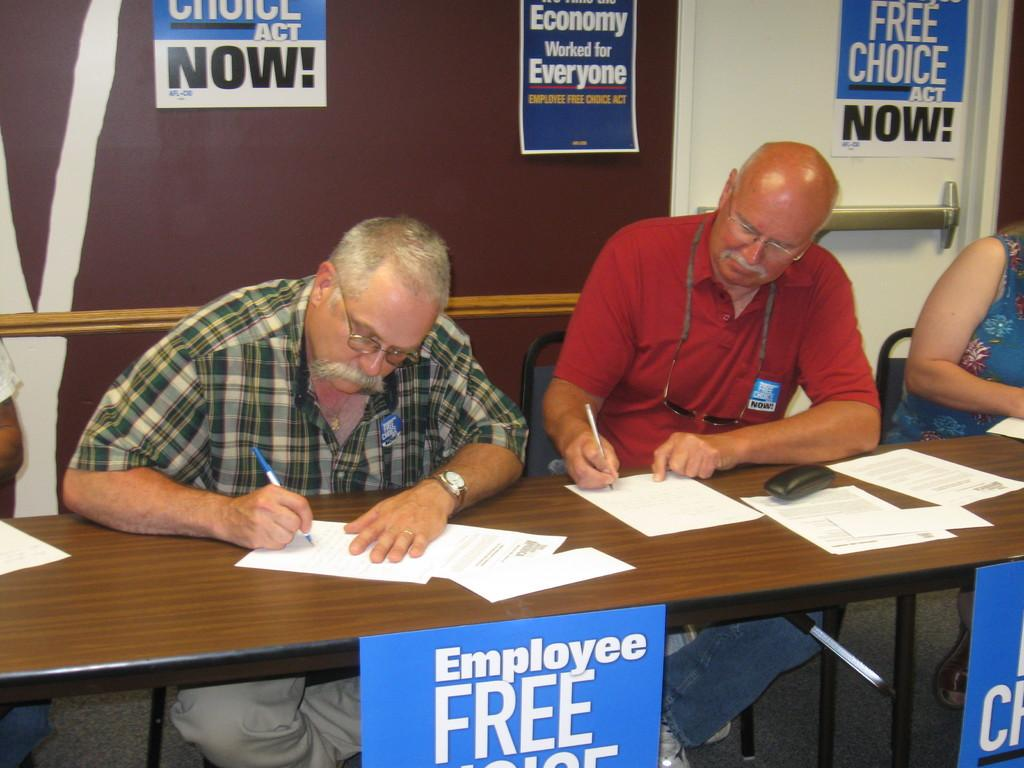How many people are present in the image? There are three individuals in the image, two men and a woman. What are the people in the image doing? They are sitting on chairs and writing on paper with a pen. Can you describe the positions of the individuals in the image? All three individuals are sitting on chairs. What type of transport is being used by the servant in the image? There is no servant or transport present in the image. What idea is the woman discussing with the men in the image? There is no discussion or idea being presented in the image; the individuals are simply writing on paper with a pen. 